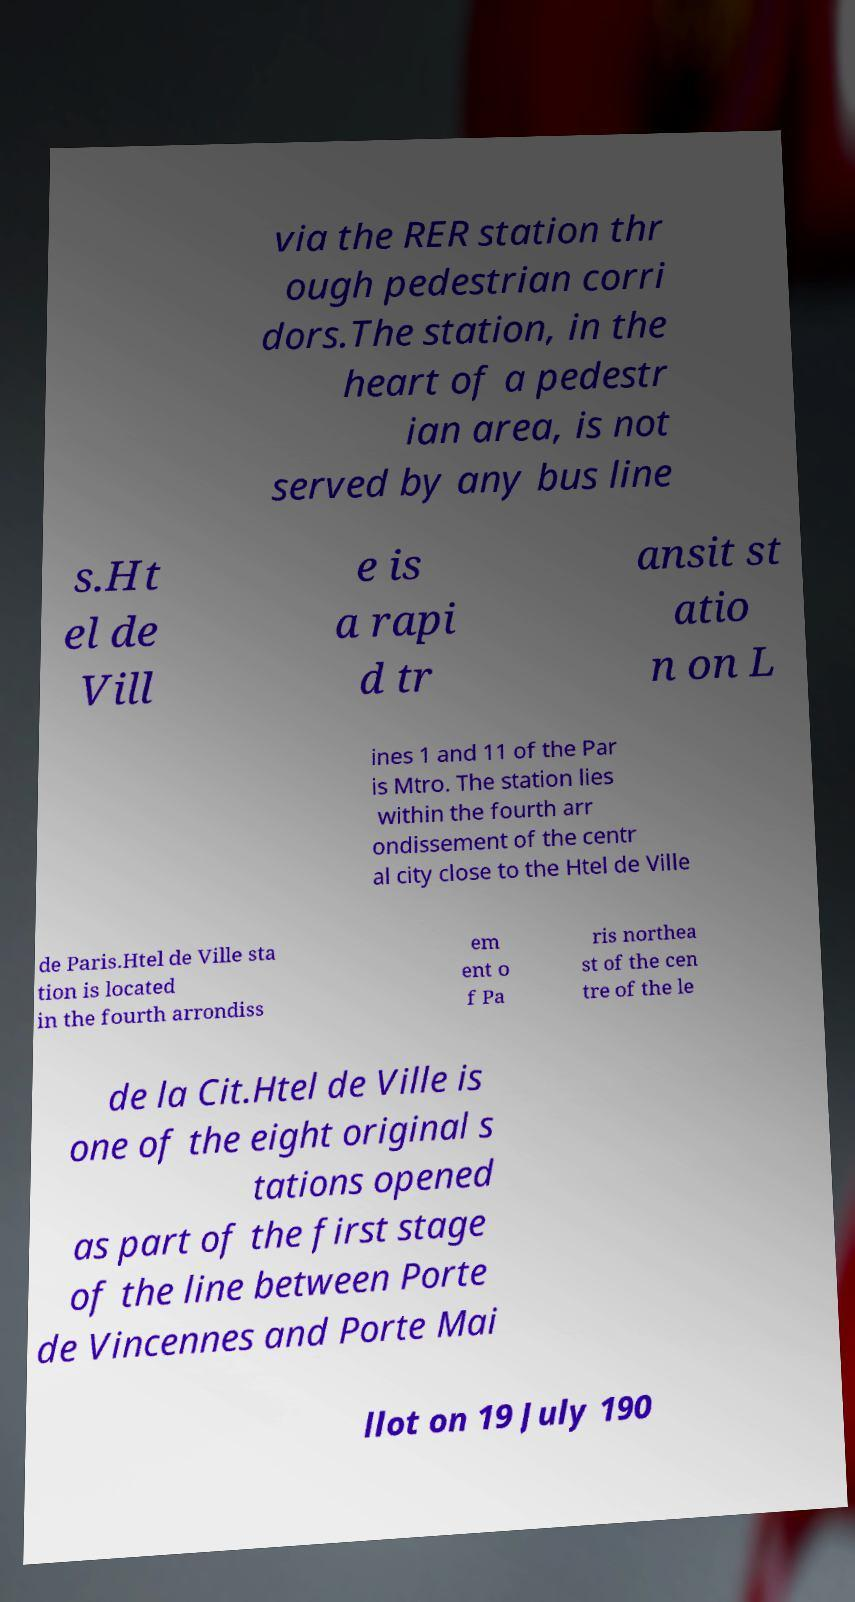There's text embedded in this image that I need extracted. Can you transcribe it verbatim? via the RER station thr ough pedestrian corri dors.The station, in the heart of a pedestr ian area, is not served by any bus line s.Ht el de Vill e is a rapi d tr ansit st atio n on L ines 1 and 11 of the Par is Mtro. The station lies within the fourth arr ondissement of the centr al city close to the Htel de Ville de Paris.Htel de Ville sta tion is located in the fourth arrondiss em ent o f Pa ris northea st of the cen tre of the le de la Cit.Htel de Ville is one of the eight original s tations opened as part of the first stage of the line between Porte de Vincennes and Porte Mai llot on 19 July 190 